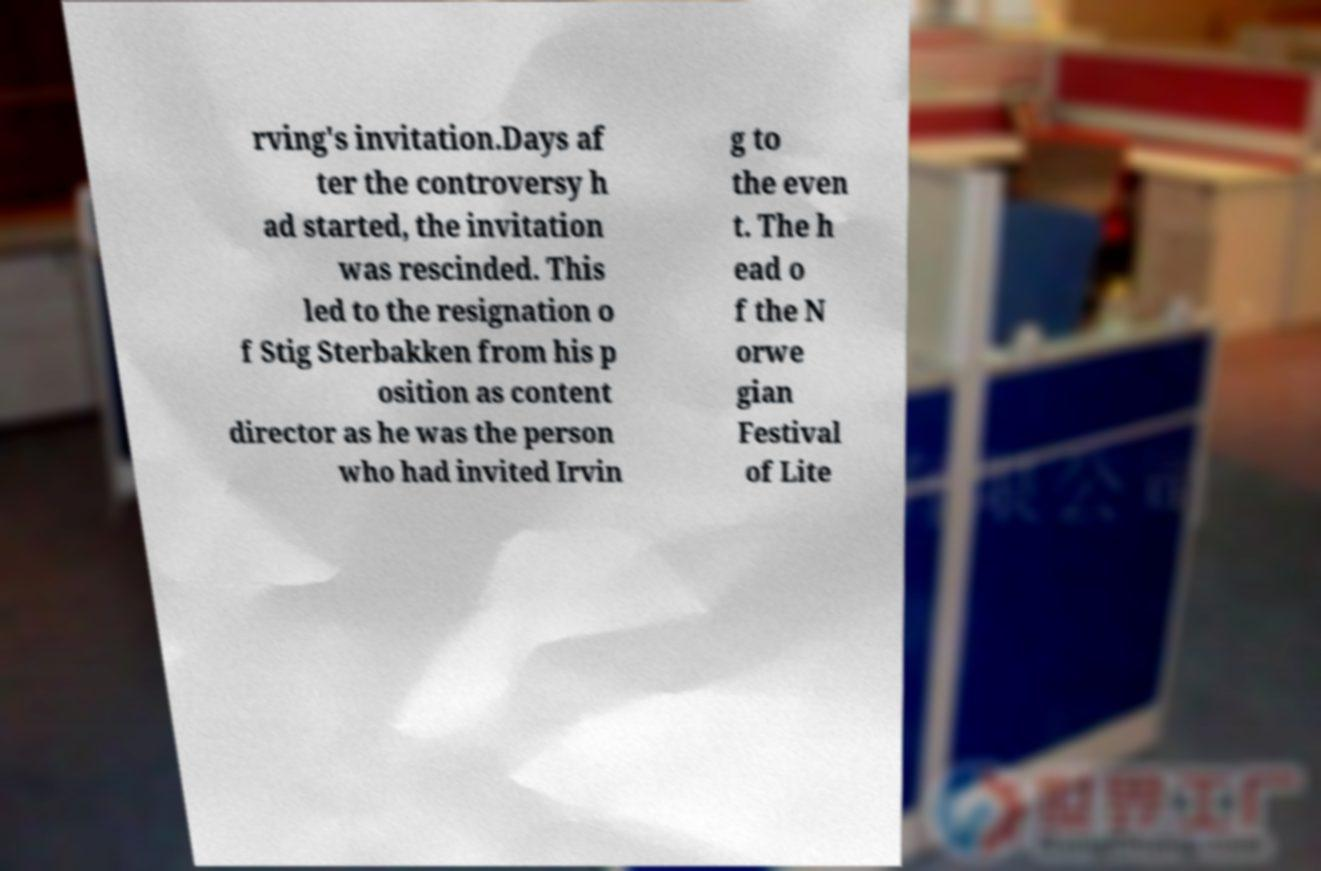There's text embedded in this image that I need extracted. Can you transcribe it verbatim? rving's invitation.Days af ter the controversy h ad started, the invitation was rescinded. This led to the resignation o f Stig Sterbakken from his p osition as content director as he was the person who had invited Irvin g to the even t. The h ead o f the N orwe gian Festival of Lite 